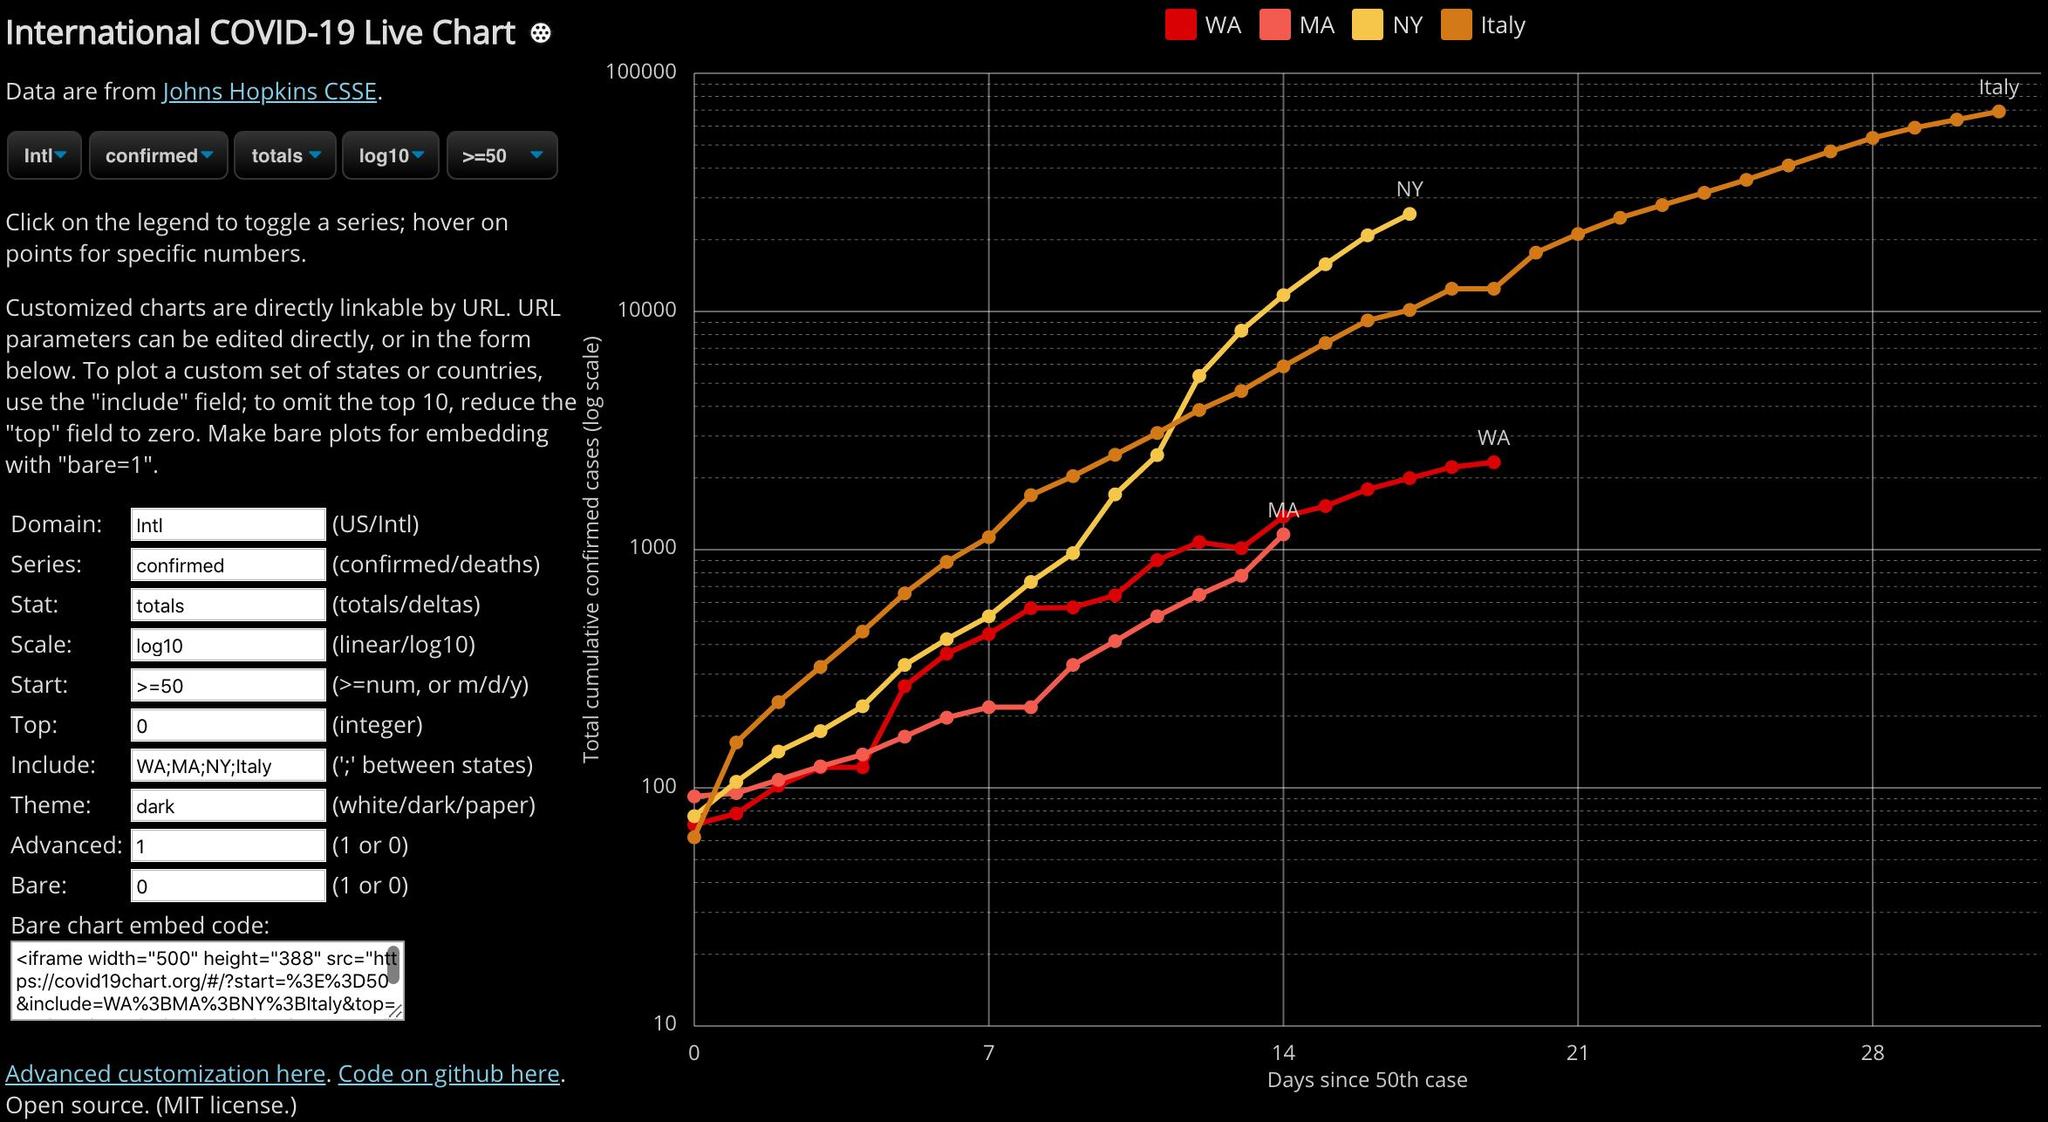Highlight a few significant elements in this photo. Italy has surpassed the 28-day mark since the 50th case was reported. The second field in the form is "Series.. The city with the second lowest total cumulative confirmed cases as of day 14 is unknown. The punctuation mark used in the "Include" field of the form is a semicolon. On day 14, Italy had the second highest total cumulative confirmed cases out of all countries. 